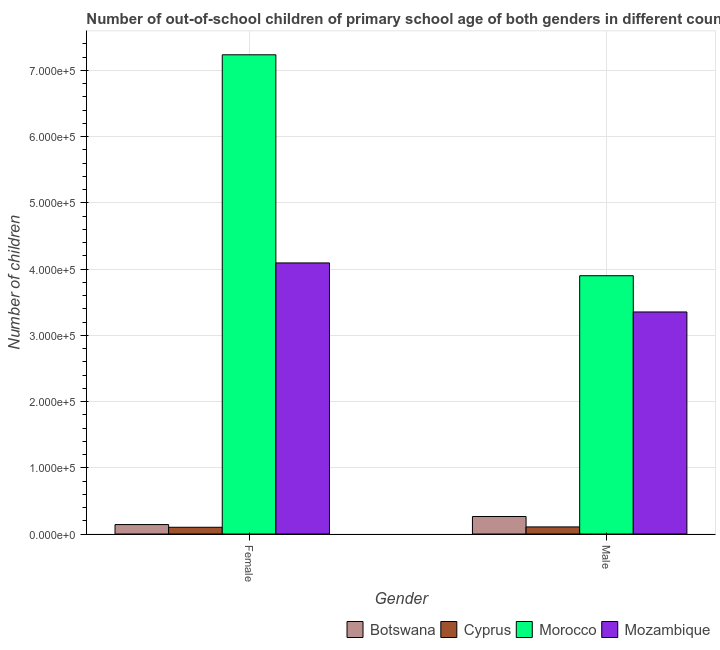How many groups of bars are there?
Offer a terse response. 2. Are the number of bars on each tick of the X-axis equal?
Give a very brief answer. Yes. What is the number of female out-of-school students in Morocco?
Your answer should be compact. 7.24e+05. Across all countries, what is the maximum number of male out-of-school students?
Ensure brevity in your answer.  3.90e+05. Across all countries, what is the minimum number of male out-of-school students?
Give a very brief answer. 1.07e+04. In which country was the number of female out-of-school students maximum?
Provide a succinct answer. Morocco. In which country was the number of male out-of-school students minimum?
Give a very brief answer. Cyprus. What is the total number of male out-of-school students in the graph?
Provide a succinct answer. 7.62e+05. What is the difference between the number of female out-of-school students in Morocco and that in Mozambique?
Give a very brief answer. 3.14e+05. What is the difference between the number of female out-of-school students in Botswana and the number of male out-of-school students in Cyprus?
Provide a succinct answer. 3538. What is the average number of female out-of-school students per country?
Your answer should be very brief. 2.89e+05. What is the difference between the number of male out-of-school students and number of female out-of-school students in Cyprus?
Your response must be concise. 533. In how many countries, is the number of male out-of-school students greater than 500000 ?
Your answer should be compact. 0. What is the ratio of the number of male out-of-school students in Cyprus to that in Mozambique?
Give a very brief answer. 0.03. In how many countries, is the number of female out-of-school students greater than the average number of female out-of-school students taken over all countries?
Keep it short and to the point. 2. What does the 1st bar from the left in Male represents?
Your answer should be compact. Botswana. What does the 1st bar from the right in Male represents?
Provide a succinct answer. Mozambique. How many bars are there?
Make the answer very short. 8. How many countries are there in the graph?
Keep it short and to the point. 4. What is the difference between two consecutive major ticks on the Y-axis?
Offer a very short reply. 1.00e+05. Does the graph contain any zero values?
Ensure brevity in your answer.  No. Does the graph contain grids?
Make the answer very short. Yes. Where does the legend appear in the graph?
Your response must be concise. Bottom right. What is the title of the graph?
Your response must be concise. Number of out-of-school children of primary school age of both genders in different countries. What is the label or title of the X-axis?
Provide a short and direct response. Gender. What is the label or title of the Y-axis?
Your answer should be very brief. Number of children. What is the Number of children of Botswana in Female?
Ensure brevity in your answer.  1.42e+04. What is the Number of children in Cyprus in Female?
Your answer should be compact. 1.02e+04. What is the Number of children in Morocco in Female?
Give a very brief answer. 7.24e+05. What is the Number of children of Mozambique in Female?
Give a very brief answer. 4.09e+05. What is the Number of children in Botswana in Male?
Provide a short and direct response. 2.64e+04. What is the Number of children in Cyprus in Male?
Ensure brevity in your answer.  1.07e+04. What is the Number of children in Morocco in Male?
Give a very brief answer. 3.90e+05. What is the Number of children of Mozambique in Male?
Provide a short and direct response. 3.35e+05. Across all Gender, what is the maximum Number of children in Botswana?
Provide a short and direct response. 2.64e+04. Across all Gender, what is the maximum Number of children in Cyprus?
Provide a short and direct response. 1.07e+04. Across all Gender, what is the maximum Number of children in Morocco?
Offer a terse response. 7.24e+05. Across all Gender, what is the maximum Number of children in Mozambique?
Provide a short and direct response. 4.09e+05. Across all Gender, what is the minimum Number of children in Botswana?
Your response must be concise. 1.42e+04. Across all Gender, what is the minimum Number of children of Cyprus?
Offer a very short reply. 1.02e+04. Across all Gender, what is the minimum Number of children of Morocco?
Make the answer very short. 3.90e+05. Across all Gender, what is the minimum Number of children of Mozambique?
Your response must be concise. 3.35e+05. What is the total Number of children of Botswana in the graph?
Your answer should be very brief. 4.07e+04. What is the total Number of children of Cyprus in the graph?
Make the answer very short. 2.09e+04. What is the total Number of children of Morocco in the graph?
Make the answer very short. 1.11e+06. What is the total Number of children of Mozambique in the graph?
Keep it short and to the point. 7.45e+05. What is the difference between the Number of children of Botswana in Female and that in Male?
Provide a succinct answer. -1.22e+04. What is the difference between the Number of children in Cyprus in Female and that in Male?
Provide a short and direct response. -533. What is the difference between the Number of children of Morocco in Female and that in Male?
Make the answer very short. 3.34e+05. What is the difference between the Number of children of Mozambique in Female and that in Male?
Make the answer very short. 7.40e+04. What is the difference between the Number of children of Botswana in Female and the Number of children of Cyprus in Male?
Make the answer very short. 3538. What is the difference between the Number of children in Botswana in Female and the Number of children in Morocco in Male?
Ensure brevity in your answer.  -3.76e+05. What is the difference between the Number of children in Botswana in Female and the Number of children in Mozambique in Male?
Your answer should be compact. -3.21e+05. What is the difference between the Number of children in Cyprus in Female and the Number of children in Morocco in Male?
Ensure brevity in your answer.  -3.80e+05. What is the difference between the Number of children of Cyprus in Female and the Number of children of Mozambique in Male?
Keep it short and to the point. -3.25e+05. What is the difference between the Number of children of Morocco in Female and the Number of children of Mozambique in Male?
Your response must be concise. 3.88e+05. What is the average Number of children in Botswana per Gender?
Ensure brevity in your answer.  2.03e+04. What is the average Number of children in Cyprus per Gender?
Offer a terse response. 1.04e+04. What is the average Number of children in Morocco per Gender?
Provide a short and direct response. 5.57e+05. What is the average Number of children of Mozambique per Gender?
Offer a terse response. 3.72e+05. What is the difference between the Number of children of Botswana and Number of children of Cyprus in Female?
Your answer should be very brief. 4071. What is the difference between the Number of children of Botswana and Number of children of Morocco in Female?
Give a very brief answer. -7.09e+05. What is the difference between the Number of children in Botswana and Number of children in Mozambique in Female?
Make the answer very short. -3.95e+05. What is the difference between the Number of children in Cyprus and Number of children in Morocco in Female?
Your answer should be compact. -7.13e+05. What is the difference between the Number of children of Cyprus and Number of children of Mozambique in Female?
Ensure brevity in your answer.  -3.99e+05. What is the difference between the Number of children in Morocco and Number of children in Mozambique in Female?
Provide a short and direct response. 3.14e+05. What is the difference between the Number of children of Botswana and Number of children of Cyprus in Male?
Ensure brevity in your answer.  1.57e+04. What is the difference between the Number of children of Botswana and Number of children of Morocco in Male?
Offer a very short reply. -3.64e+05. What is the difference between the Number of children in Botswana and Number of children in Mozambique in Male?
Offer a terse response. -3.09e+05. What is the difference between the Number of children of Cyprus and Number of children of Morocco in Male?
Your response must be concise. -3.79e+05. What is the difference between the Number of children of Cyprus and Number of children of Mozambique in Male?
Your answer should be compact. -3.25e+05. What is the difference between the Number of children of Morocco and Number of children of Mozambique in Male?
Make the answer very short. 5.47e+04. What is the ratio of the Number of children in Botswana in Female to that in Male?
Offer a terse response. 0.54. What is the ratio of the Number of children of Cyprus in Female to that in Male?
Your response must be concise. 0.95. What is the ratio of the Number of children in Morocco in Female to that in Male?
Offer a terse response. 1.86. What is the ratio of the Number of children in Mozambique in Female to that in Male?
Provide a short and direct response. 1.22. What is the difference between the highest and the second highest Number of children in Botswana?
Offer a terse response. 1.22e+04. What is the difference between the highest and the second highest Number of children of Cyprus?
Ensure brevity in your answer.  533. What is the difference between the highest and the second highest Number of children of Morocco?
Offer a very short reply. 3.34e+05. What is the difference between the highest and the second highest Number of children of Mozambique?
Offer a terse response. 7.40e+04. What is the difference between the highest and the lowest Number of children of Botswana?
Give a very brief answer. 1.22e+04. What is the difference between the highest and the lowest Number of children in Cyprus?
Provide a short and direct response. 533. What is the difference between the highest and the lowest Number of children of Morocco?
Keep it short and to the point. 3.34e+05. What is the difference between the highest and the lowest Number of children in Mozambique?
Ensure brevity in your answer.  7.40e+04. 